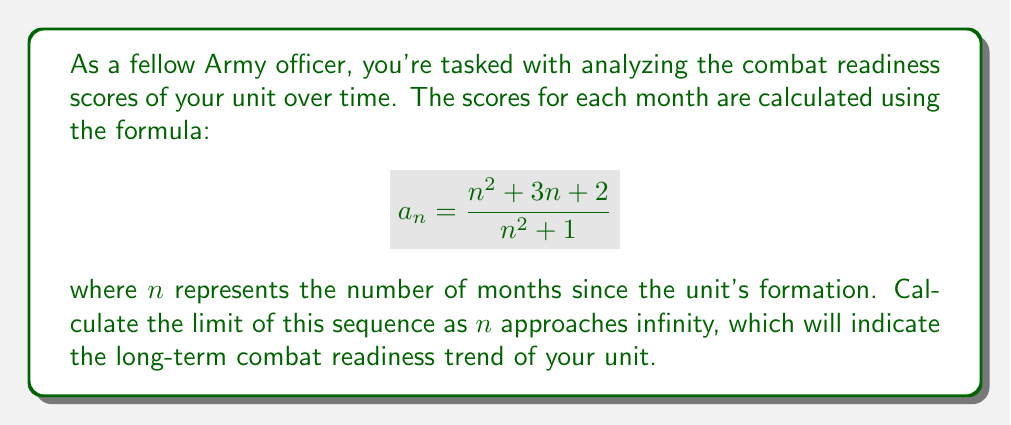What is the answer to this math problem? Let's approach this step-by-step:

1) To find the limit of the sequence as $n$ approaches infinity, we need to analyze the behavior of the fraction for very large values of $n$.

2) Let's look at the numerator and denominator separately:
   Numerator: $n^2 + 3n + 2$
   Denominator: $n^2 + 1$

3) For very large $n$, the highest degree term will dominate. In both the numerator and denominator, this is $n^2$.

4) We can factor out $n^2$ from both:
   $$ \lim_{n \to \infty} \frac{n^2 + 3n + 2}{n^2 + 1} = \lim_{n \to \infty} \frac{n^2(1 + \frac{3}{n} + \frac{2}{n^2})}{n^2(1 + \frac{1}{n^2})} $$

5) The $n^2$ terms cancel out:
   $$ \lim_{n \to \infty} \frac{1 + \frac{3}{n} + \frac{2}{n^2}}{1 + \frac{1}{n^2}} $$

6) As $n$ approaches infinity, $\frac{1}{n}$ and $\frac{1}{n^2}$ approach 0:
   $$ \lim_{n \to \infty} \frac{1 + 0 + 0}{1 + 0} = \frac{1}{1} = 1 $$

Therefore, the limit of the sequence as $n$ approaches infinity is 1, indicating that the long-term combat readiness trend of your unit stabilizes at 1.
Answer: 1 